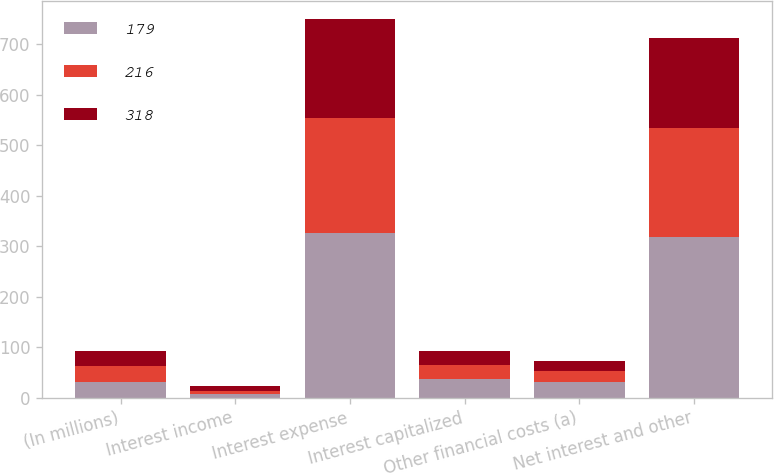Convert chart to OTSL. <chart><loc_0><loc_0><loc_500><loc_500><stacked_bar_chart><ecel><fcel>(In millions)<fcel>Interest income<fcel>Interest expense<fcel>Interest capitalized<fcel>Other financial costs (a)<fcel>Net interest and other<nl><fcel>179<fcel>31<fcel>6<fcel>325<fcel>37<fcel>31<fcel>318<nl><fcel>216<fcel>31<fcel>7<fcel>229<fcel>27<fcel>21<fcel>216<nl><fcel>318<fcel>31<fcel>9<fcel>195<fcel>28<fcel>21<fcel>179<nl></chart> 